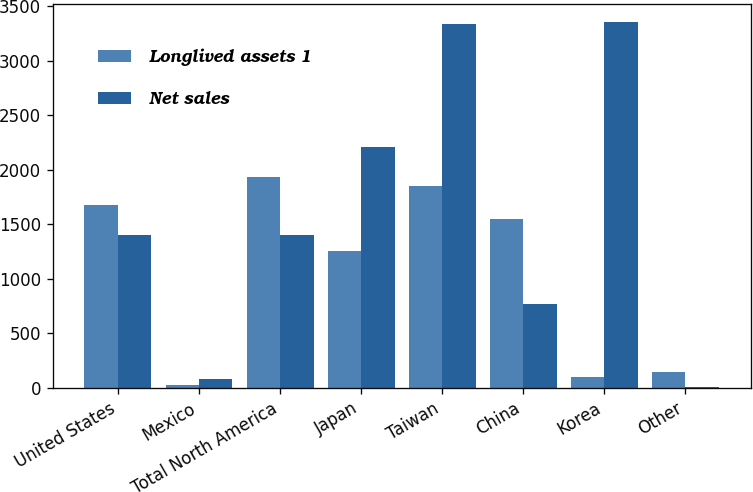Convert chart to OTSL. <chart><loc_0><loc_0><loc_500><loc_500><stacked_bar_chart><ecel><fcel>United States<fcel>Mexico<fcel>Total North America<fcel>Japan<fcel>Taiwan<fcel>China<fcel>Korea<fcel>Other<nl><fcel>Longlived assets 1<fcel>1676<fcel>26<fcel>1931<fcel>1252<fcel>1850<fcel>1550<fcel>101<fcel>145<nl><fcel>Net sales<fcel>1401<fcel>78<fcel>1401<fcel>2210<fcel>3341<fcel>764<fcel>3357<fcel>11<nl></chart> 